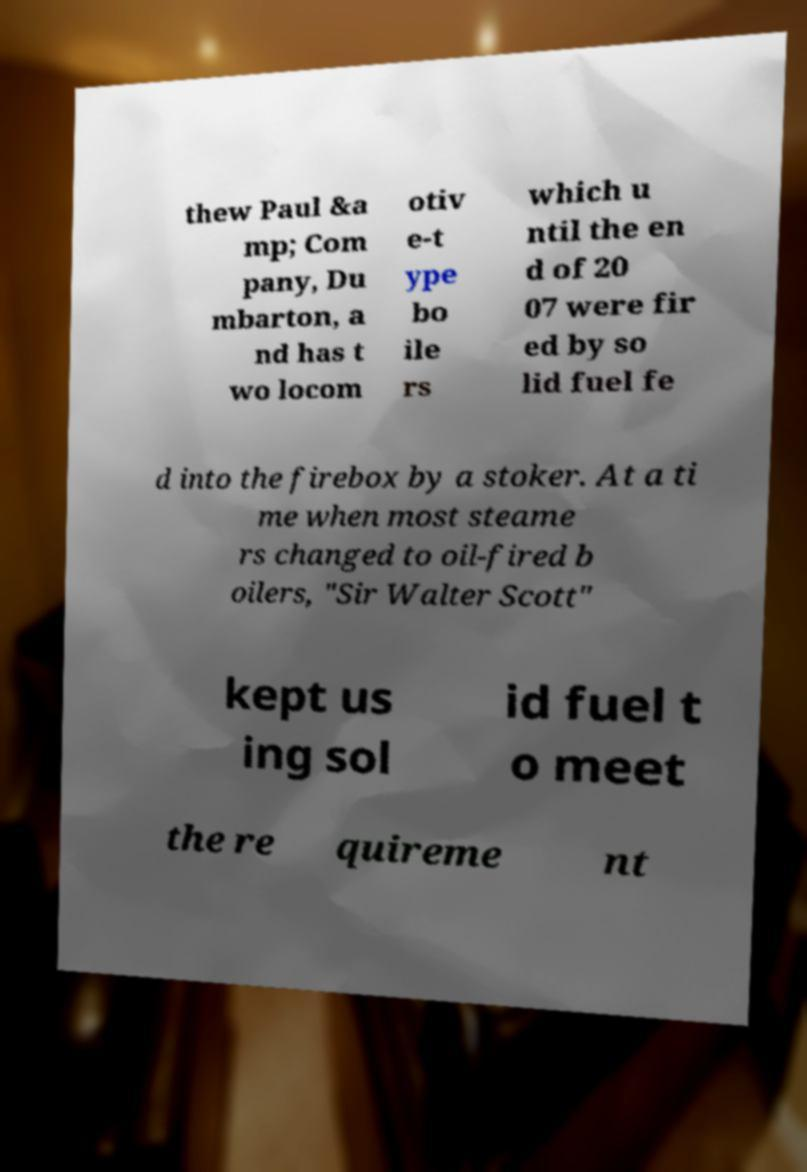What messages or text are displayed in this image? I need them in a readable, typed format. thew Paul &a mp; Com pany, Du mbarton, a nd has t wo locom otiv e-t ype bo ile rs which u ntil the en d of 20 07 were fir ed by so lid fuel fe d into the firebox by a stoker. At a ti me when most steame rs changed to oil-fired b oilers, "Sir Walter Scott" kept us ing sol id fuel t o meet the re quireme nt 